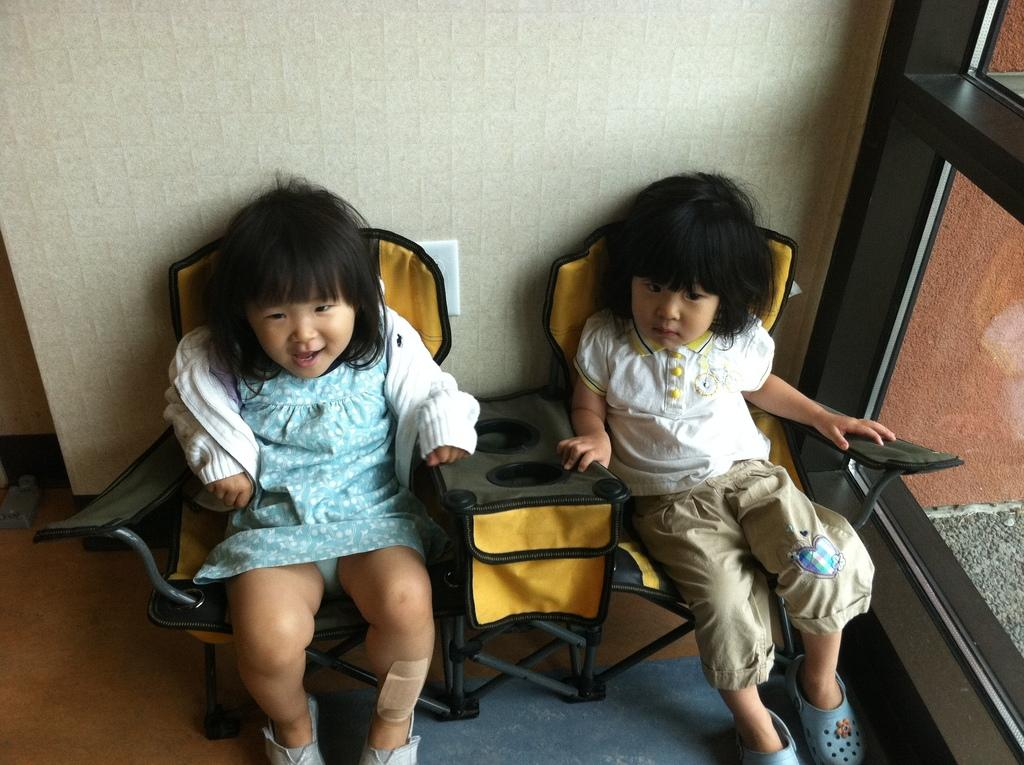How many kids are in the image? There are two Asian kids in the image. What are the kids doing in the image? The kids are sitting on chairs. How are the kids' haircuts styled? The kids have baby haircuts. What color is the background wall in the image? The background wall is cream in color. What is beside the kids in the image? There is a glass window beside the kids. How many spiders are crawling on the kids in the image? There are no spiders visible in the image; the kids are sitting on chairs with a cream-colored background wall and a glass window beside them. 